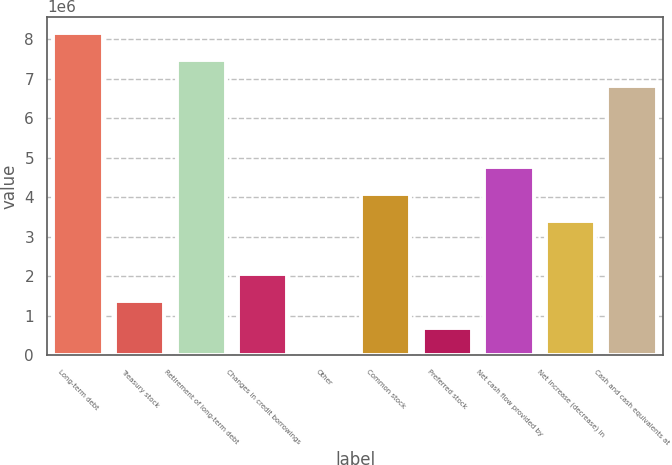Convert chart. <chart><loc_0><loc_0><loc_500><loc_500><bar_chart><fcel>Long-term debt<fcel>Treasury stock<fcel>Retirement of long-term debt<fcel>Changes in credit borrowings<fcel>Other<fcel>Common stock<fcel>Preferred stock<fcel>Net cash flow provided by<fcel>Net increase (decrease) in<fcel>Cash and cash equivalents at<nl><fcel>8.1593e+06<fcel>1.36561e+06<fcel>7.47993e+06<fcel>2.04498e+06<fcel>6872<fcel>4.08308e+06<fcel>686241<fcel>4.76245e+06<fcel>3.40372e+06<fcel>6.80056e+06<nl></chart> 